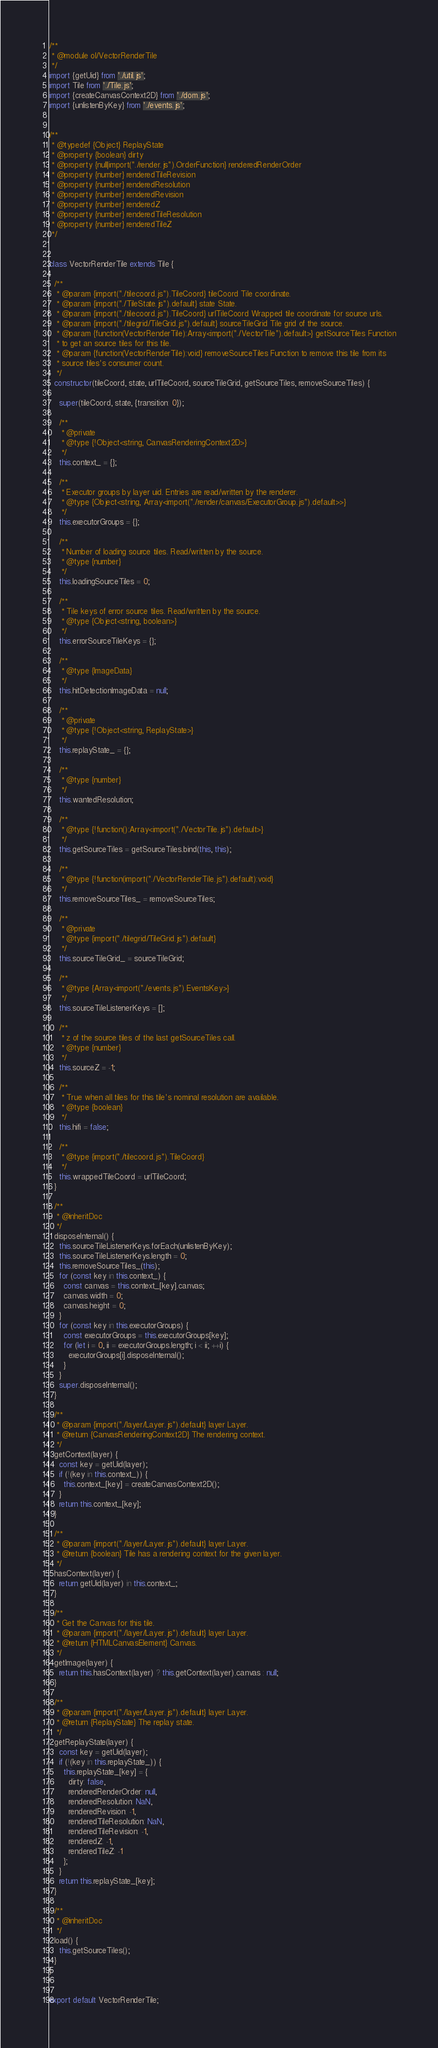Convert code to text. <code><loc_0><loc_0><loc_500><loc_500><_JavaScript_>/**
 * @module ol/VectorRenderTile
 */
import {getUid} from './util.js';
import Tile from './Tile.js';
import {createCanvasContext2D} from './dom.js';
import {unlistenByKey} from './events.js';


/**
 * @typedef {Object} ReplayState
 * @property {boolean} dirty
 * @property {null|import("./render.js").OrderFunction} renderedRenderOrder
 * @property {number} renderedTileRevision
 * @property {number} renderedResolution
 * @property {number} renderedRevision
 * @property {number} renderedZ
 * @property {number} renderedTileResolution
 * @property {number} renderedTileZ
 */


class VectorRenderTile extends Tile {

  /**
   * @param {import("./tilecoord.js").TileCoord} tileCoord Tile coordinate.
   * @param {import("./TileState.js").default} state State.
   * @param {import("./tilecoord.js").TileCoord} urlTileCoord Wrapped tile coordinate for source urls.
   * @param {import("./tilegrid/TileGrid.js").default} sourceTileGrid Tile grid of the source.
   * @param {function(VectorRenderTile):Array<import("./VectorTile").default>} getSourceTiles Function
   * to get an source tiles for this tile.
   * @param {function(VectorRenderTile):void} removeSourceTiles Function to remove this tile from its
   * source tiles's consumer count.
   */
  constructor(tileCoord, state, urlTileCoord, sourceTileGrid, getSourceTiles, removeSourceTiles) {

    super(tileCoord, state, {transition: 0});

    /**
     * @private
     * @type {!Object<string, CanvasRenderingContext2D>}
     */
    this.context_ = {};

    /**
     * Executor groups by layer uid. Entries are read/written by the renderer.
     * @type {Object<string, Array<import("./render/canvas/ExecutorGroup.js").default>>}
     */
    this.executorGroups = {};

    /**
     * Number of loading source tiles. Read/written by the source.
     * @type {number}
     */
    this.loadingSourceTiles = 0;

    /**
     * Tile keys of error source tiles. Read/written by the source.
     * @type {Object<string, boolean>}
     */
    this.errorSourceTileKeys = {};

    /**
     * @type {ImageData}
     */
    this.hitDetectionImageData = null;

    /**
     * @private
     * @type {!Object<string, ReplayState>}
     */
    this.replayState_ = {};

    /**
     * @type {number}
     */
    this.wantedResolution;

    /**
     * @type {!function():Array<import("./VectorTile.js").default>}
     */
    this.getSourceTiles = getSourceTiles.bind(this, this);

    /**
     * @type {!function(import("./VectorRenderTile.js").default):void}
     */
    this.removeSourceTiles_ = removeSourceTiles;

    /**
     * @private
     * @type {import("./tilegrid/TileGrid.js").default}
     */
    this.sourceTileGrid_ = sourceTileGrid;

    /**
     * @type {Array<import("./events.js").EventsKey>}
     */
    this.sourceTileListenerKeys = [];

    /**
     * z of the source tiles of the last getSourceTiles call.
     * @type {number}
     */
    this.sourceZ = -1;

    /**
     * True when all tiles for this tile's nominal resolution are available.
     * @type {boolean}
     */
    this.hifi = false;

    /**
     * @type {import("./tilecoord.js").TileCoord}
     */
    this.wrappedTileCoord = urlTileCoord;
  }

  /**
   * @inheritDoc
   */
  disposeInternal() {
    this.sourceTileListenerKeys.forEach(unlistenByKey);
    this.sourceTileListenerKeys.length = 0;
    this.removeSourceTiles_(this);
    for (const key in this.context_) {
      const canvas = this.context_[key].canvas;
      canvas.width = 0;
      canvas.height = 0;
    }
    for (const key in this.executorGroups) {
      const executorGroups = this.executorGroups[key];
      for (let i = 0, ii = executorGroups.length; i < ii; ++i) {
        executorGroups[i].disposeInternal();
      }
    }
    super.disposeInternal();
  }

  /**
   * @param {import("./layer/Layer.js").default} layer Layer.
   * @return {CanvasRenderingContext2D} The rendering context.
   */
  getContext(layer) {
    const key = getUid(layer);
    if (!(key in this.context_)) {
      this.context_[key] = createCanvasContext2D();
    }
    return this.context_[key];
  }

  /**
   * @param {import("./layer/Layer.js").default} layer Layer.
   * @return {boolean} Tile has a rendering context for the given layer.
   */
  hasContext(layer) {
    return getUid(layer) in this.context_;
  }

  /**
   * Get the Canvas for this tile.
   * @param {import("./layer/Layer.js").default} layer Layer.
   * @return {HTMLCanvasElement} Canvas.
   */
  getImage(layer) {
    return this.hasContext(layer) ? this.getContext(layer).canvas : null;
  }

  /**
   * @param {import("./layer/Layer.js").default} layer Layer.
   * @return {ReplayState} The replay state.
   */
  getReplayState(layer) {
    const key = getUid(layer);
    if (!(key in this.replayState_)) {
      this.replayState_[key] = {
        dirty: false,
        renderedRenderOrder: null,
        renderedResolution: NaN,
        renderedRevision: -1,
        renderedTileResolution: NaN,
        renderedTileRevision: -1,
        renderedZ: -1,
        renderedTileZ: -1
      };
    }
    return this.replayState_[key];
  }

  /**
   * @inheritDoc
   */
  load() {
    this.getSourceTiles();
  }
}


export default VectorRenderTile;
</code> 